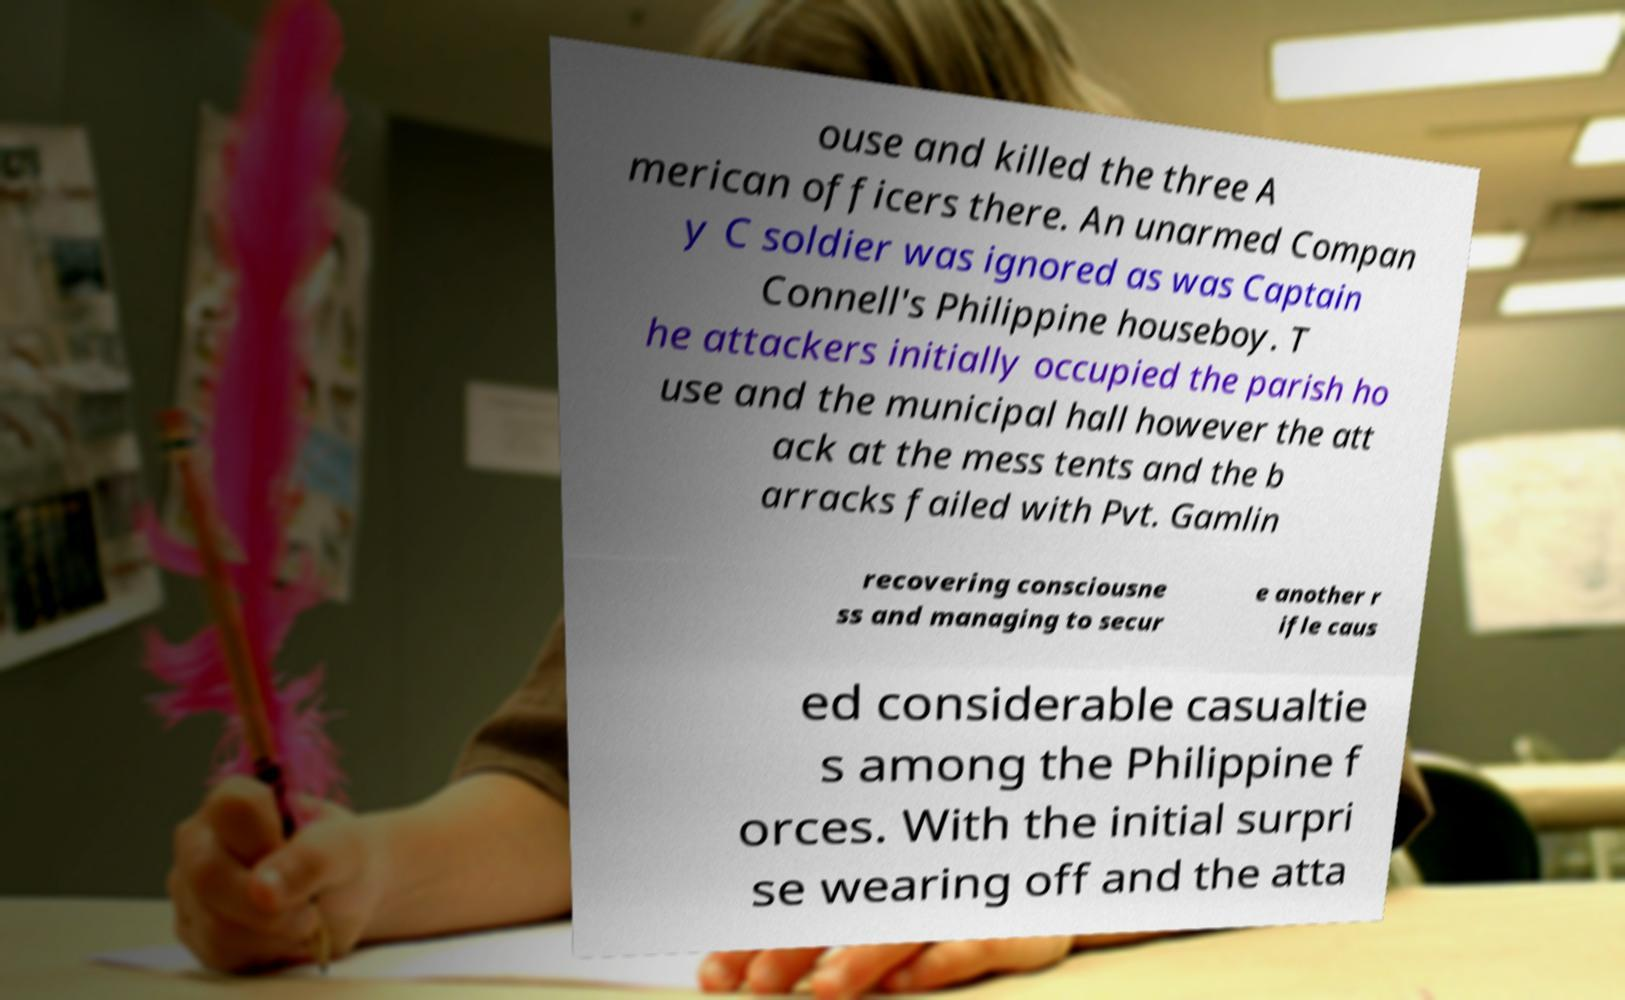I need the written content from this picture converted into text. Can you do that? ouse and killed the three A merican officers there. An unarmed Compan y C soldier was ignored as was Captain Connell's Philippine houseboy. T he attackers initially occupied the parish ho use and the municipal hall however the att ack at the mess tents and the b arracks failed with Pvt. Gamlin recovering consciousne ss and managing to secur e another r ifle caus ed considerable casualtie s among the Philippine f orces. With the initial surpri se wearing off and the atta 